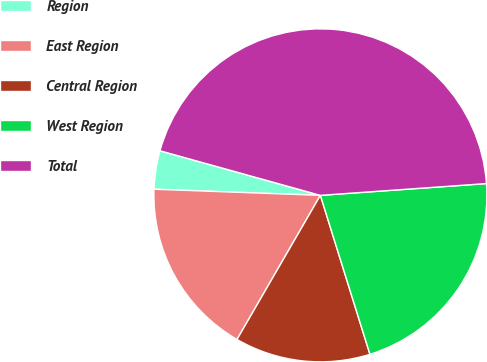<chart> <loc_0><loc_0><loc_500><loc_500><pie_chart><fcel>Region<fcel>East Region<fcel>Central Region<fcel>West Region<fcel>Total<nl><fcel>3.73%<fcel>17.24%<fcel>13.16%<fcel>21.32%<fcel>44.56%<nl></chart> 